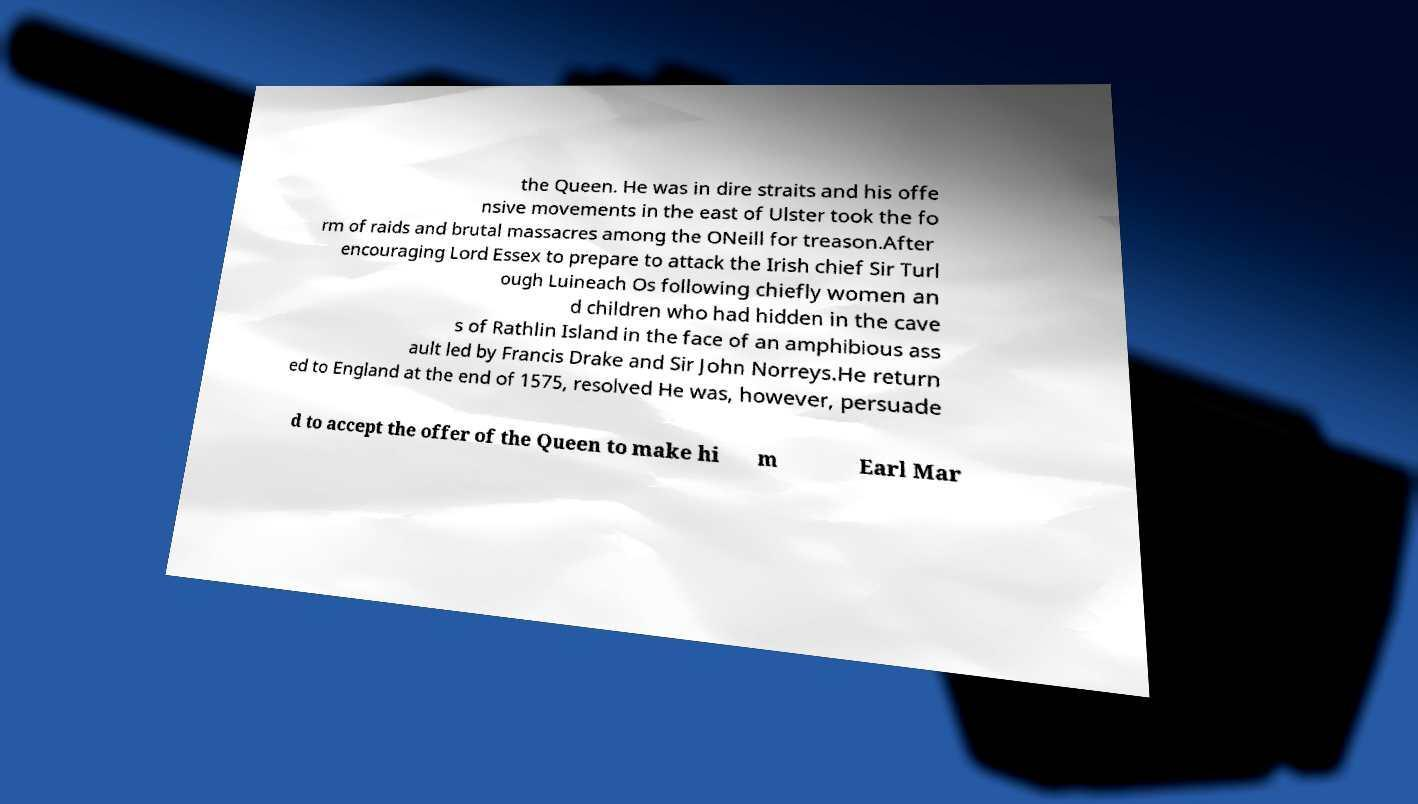Could you extract and type out the text from this image? the Queen. He was in dire straits and his offe nsive movements in the east of Ulster took the fo rm of raids and brutal massacres among the ONeill for treason.After encouraging Lord Essex to prepare to attack the Irish chief Sir Turl ough Luineach Os following chiefly women an d children who had hidden in the cave s of Rathlin Island in the face of an amphibious ass ault led by Francis Drake and Sir John Norreys.He return ed to England at the end of 1575, resolved He was, however, persuade d to accept the offer of the Queen to make hi m Earl Mar 